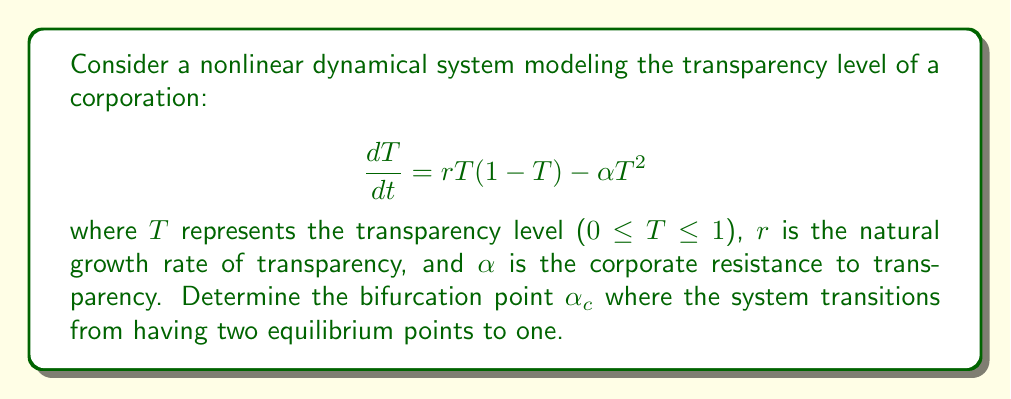Help me with this question. 1) First, find the equilibrium points by setting $\frac{dT}{dt} = 0$:

   $$rT(1-T) - \alpha T^2 = 0$$

2) Factor out T:

   $$T(r(1-T) - \alpha T) = 0$$

3) Solve for T:
   
   $T = 0$ or $r(1-T) - \alpha T = 0$

4) For the second equation:
   
   $r - rT - \alpha T = 0$
   $r = (r + \alpha)T$
   $T = \frac{r}{r + \alpha}$

5) The system has two equilibrium points: $T_1 = 0$ and $T_2 = \frac{r}{r + \alpha}$

6) The bifurcation occurs when these two points coincide, i.e., when $T_2 = 0$

7) This happens when the denominator of $T_2$ approaches infinity:

   $$\lim_{\alpha \to \infty} \frac{r}{r + \alpha} = 0$$

8) However, we need a finite value for $\alpha_c$. The bifurcation actually occurs when $T_2$ becomes negative, which is not meaningful for transparency levels.

9) $T_2$ becomes negative when $r < 0$, or when $\frac{r}{r + \alpha} < 0$

10) Since $r > 0$ (natural growth rate), the latter condition occurs when $r + \alpha < 0$

11) Solve for $\alpha$:

    $\alpha < -r$

12) The critical value $\alpha_c$ is thus:

    $\alpha_c = r$
Answer: $\alpha_c = r$ 